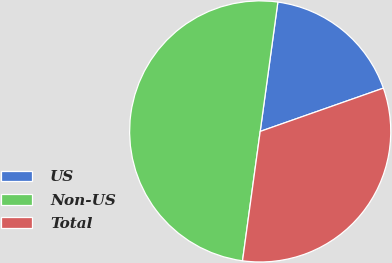Convert chart. <chart><loc_0><loc_0><loc_500><loc_500><pie_chart><fcel>US<fcel>Non-US<fcel>Total<nl><fcel>17.46%<fcel>50.0%<fcel>32.54%<nl></chart> 